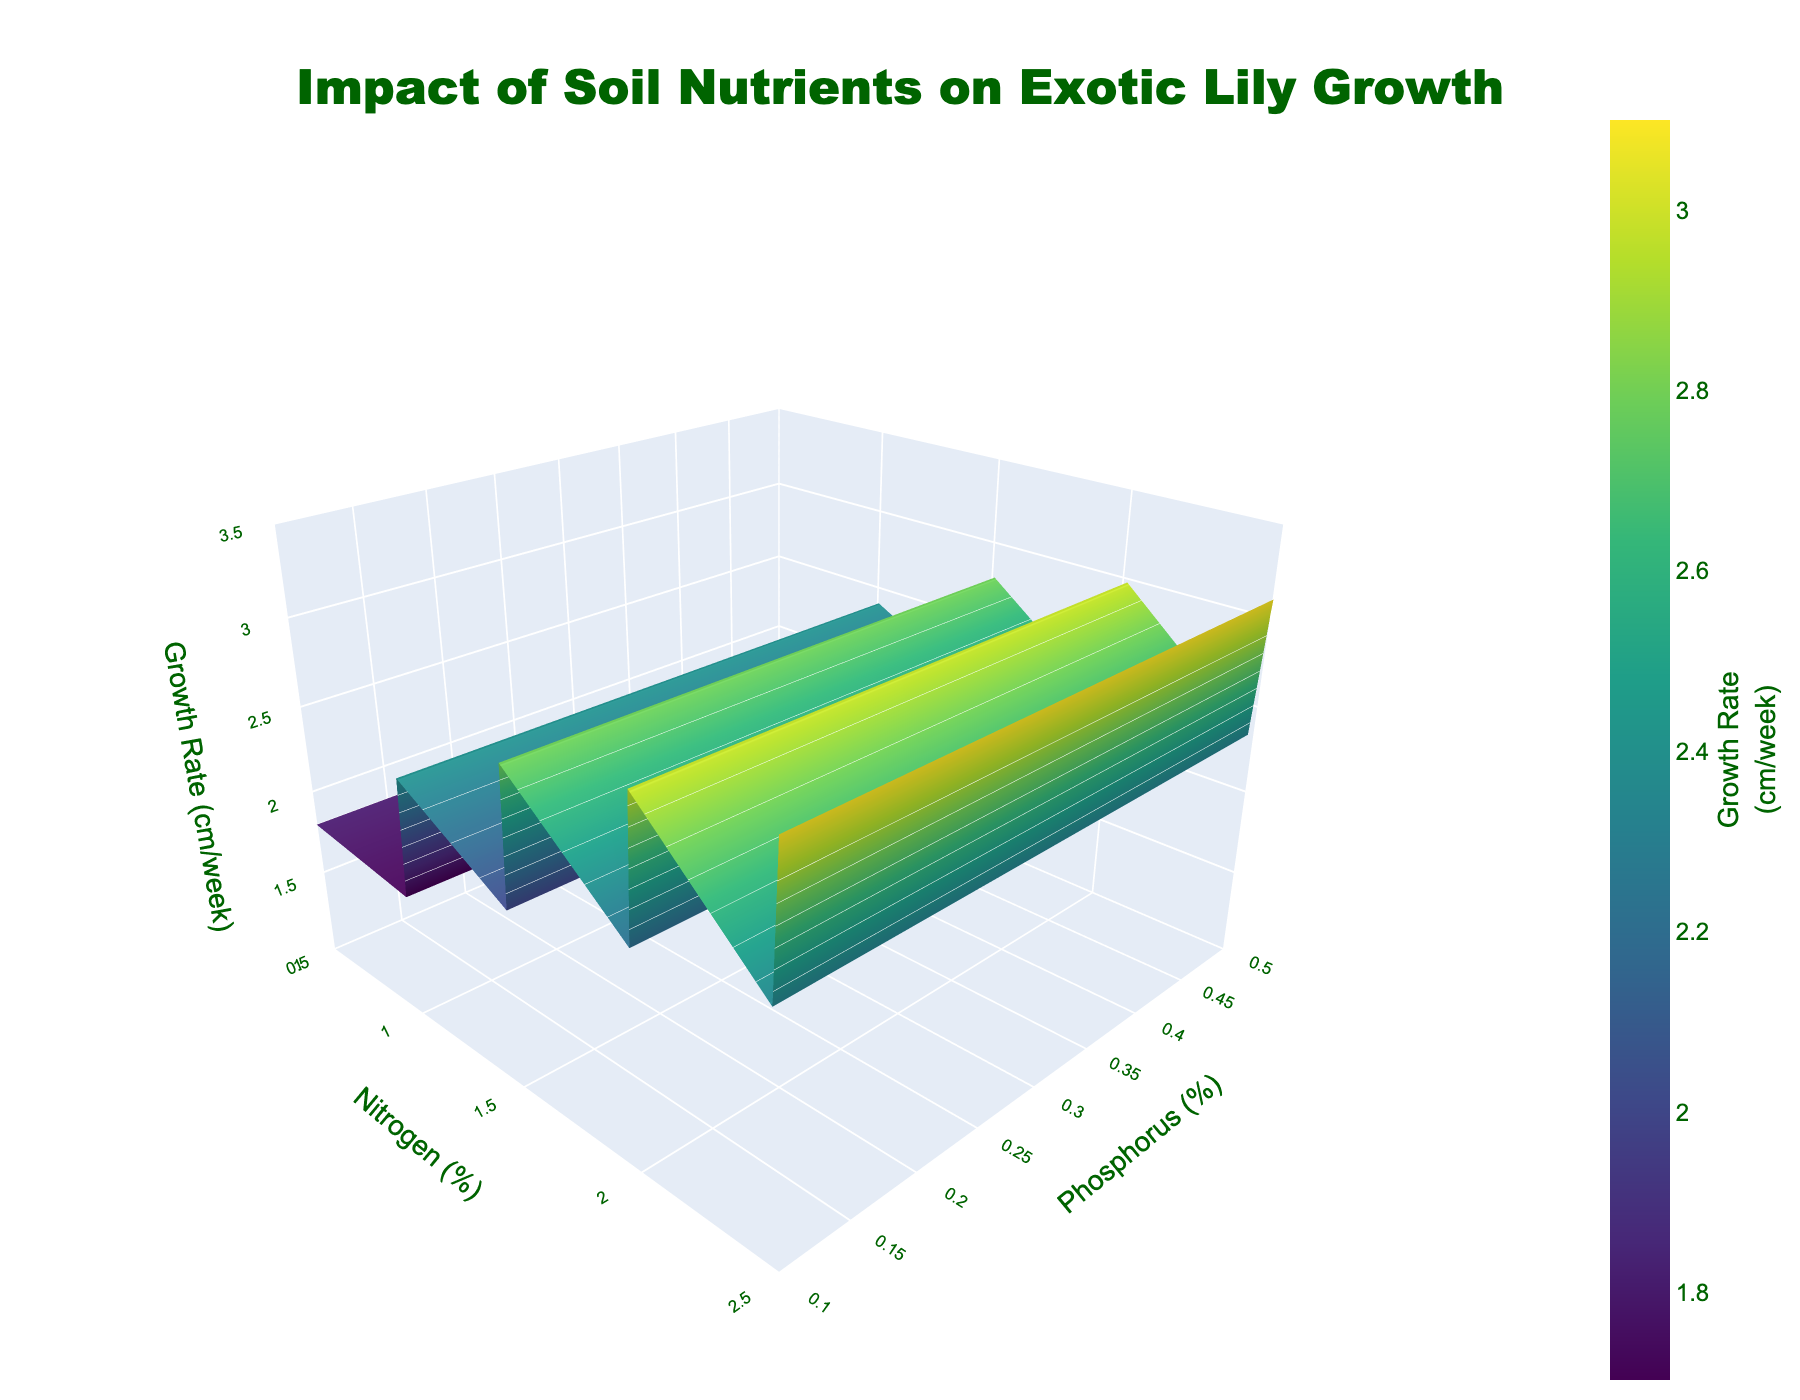What is the main title of the 3D surface plot? The title is located at the top center of the 3D plot in a larger font size, which reads "Impact of Soil Nutrients on Exotic Lily Growth".
Answer: Impact of Soil Nutrients on Exotic Lily Growth Which axes represent Nitrogen and Phosphorus percentages? In 3D plots, axis titles are clearly labeled. The x-axis represents Nitrogen (%), and the y-axis represents Phosphorus (%).
Answer: x-axis: Nitrogen (%), y-axis: Phosphorus (%) What color scheme is used for the growth rate in the plot? The plot uses a continuous color scale to represent growth rates, specifically the 'Viridis' colorscale, which ranges from dark blue to yellow.
Answer: Viridis (dark blue to yellow) Which combination of Nitrogen and Phosphorus results in the highest average growth rate? By inspecting the 3D surface plot, the highest point on the z-axis (Growth Rate) occurs at the combination of Nitrogen at 2.5% and Phosphorus at 0.5%.
Answer: Nitrogen: 2.5%, Phosphorus: 0.5% What range of growth rates (cm/week) is displayed in the plot? The colorbar on the right side of the 3D surface plot indicates the range of growth rates displayed. The growth rates range from 1 cm/week to 3.5 cm/week.
Answer: 1 to 3.5 cm/week Comparing Nitrogen levels at 0.5% and 1.5%, which Phosphorus level (within the given range) produces the highest growth rate? From the plot, at 0.5% Nitrogen, the growth rate increases with increasing Phosphorus, reaching around 1.8 cm/week at 0.5% Phosphorus. At 1.5% Nitrogen, the highest growth rate is about 2.8 cm/week also at 0.5% Phosphorus.
Answer: Nitrogen: 1.5%, Phosphorus: 0.5% How does the growth rate change as both Nitrogen and Phosphorus levels are increased simultaneously? By examining the surface plot, it is clear that as both Nitrogen and Phosphorus percentages increase, the growth rate generally increases, showing a rising trend on the z-axis.
Answer: Generally increases If the target growth rate is at least 3.0 cm/week, what is the minimum Nitrogen and Phosphorus combination required? From the plot, the lowest combination to achieve a growth rate of at least 3.0 cm/week is Nitrogen at 2.0% and Phosphorus at 0.5%.
Answer: Nitrogen: 2.0%, Phosphorus: 0.5% Does an increase in Phosphorus always result in a higher growth rate for a fixed Nitrogen level? Observing the plot across different Nitrogen levels, an increase in Phosphorus always leads to an increase in growth rate, showing a consistent upward trend along the y-axis.
Answer: Yes 